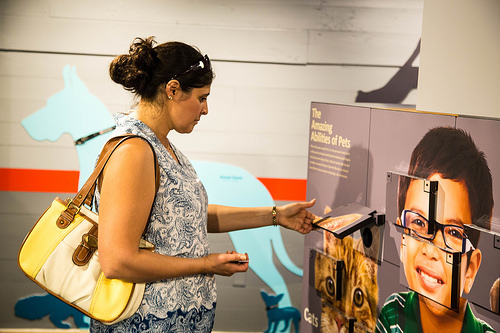<image>
Can you confirm if the boy is next to the bag? No. The boy is not positioned next to the bag. They are located in different areas of the scene. 